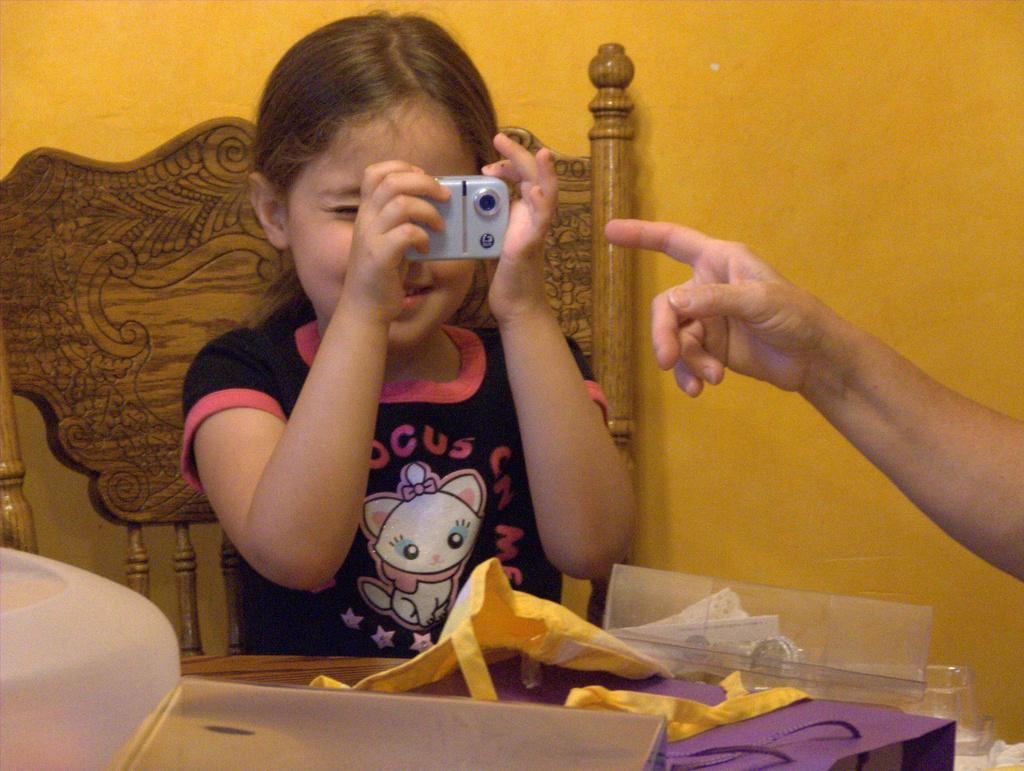Who is the main subject in the image? There is a girl in the image. What is the girl doing in the image? The girl is sitting on a chair and holding a camera in her hand. What can be seen in the background of the image? There is a yellow color wall in the background. What type of rock is the girl climbing in the image? There is no rock present in the image; the girl is sitting on a chair and holding a camera. 